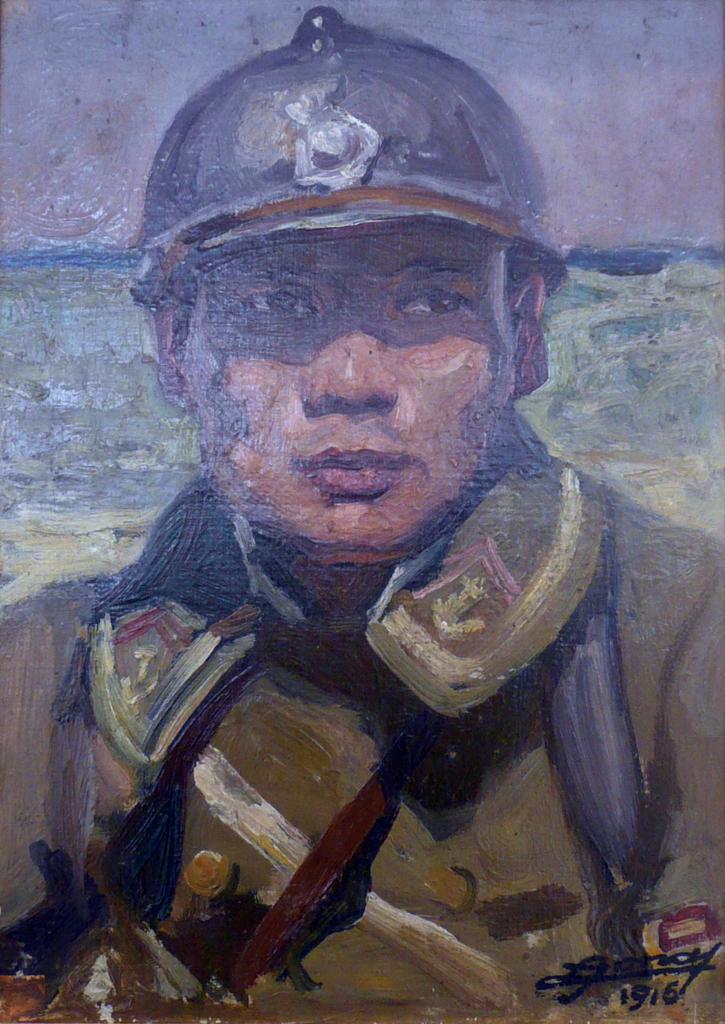Please provide a concise description of this image. In this image there is a painting of a man, in the bottom right there is some text. 